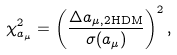Convert formula to latex. <formula><loc_0><loc_0><loc_500><loc_500>\chi ^ { 2 } _ { a _ { \mu } } = \left ( \frac { \Delta a _ { \mu , \text {2HDM} } } { \sigma ( a _ { \mu } ) } \right ) ^ { 2 } ,</formula> 